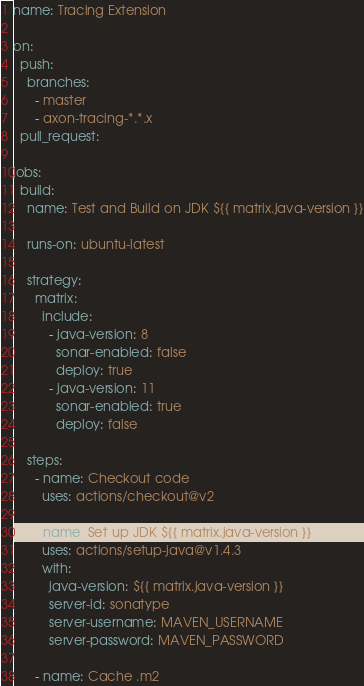Convert code to text. <code><loc_0><loc_0><loc_500><loc_500><_YAML_>name: Tracing Extension

on:
  push:
    branches:
      - master
      - axon-tracing-*.*.x
  pull_request:

jobs:
  build:
    name: Test and Build on JDK ${{ matrix.java-version }}

    runs-on: ubuntu-latest

    strategy:
      matrix:
        include:
          - java-version: 8
            sonar-enabled: false
            deploy: true
          - java-version: 11
            sonar-enabled: true
            deploy: false

    steps:
      - name: Checkout code
        uses: actions/checkout@v2

      - name: Set up JDK ${{ matrix.java-version }}
        uses: actions/setup-java@v1.4.3
        with:
          java-version: ${{ matrix.java-version }}
          server-id: sonatype
          server-username: MAVEN_USERNAME
          server-password: MAVEN_PASSWORD

      - name: Cache .m2</code> 